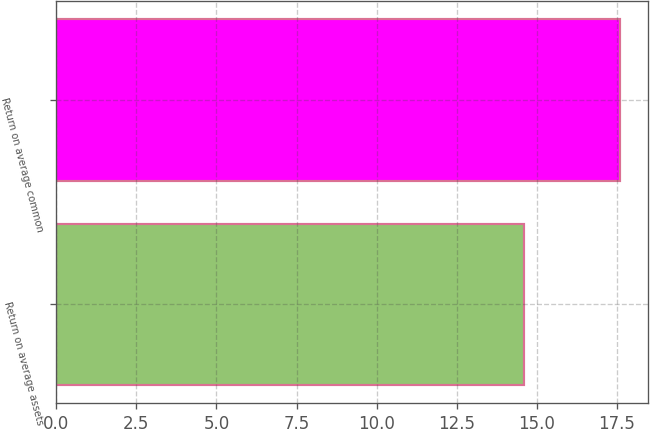Convert chart. <chart><loc_0><loc_0><loc_500><loc_500><bar_chart><fcel>Return on average assets<fcel>Return on average common<nl><fcel>14.6<fcel>17.6<nl></chart> 